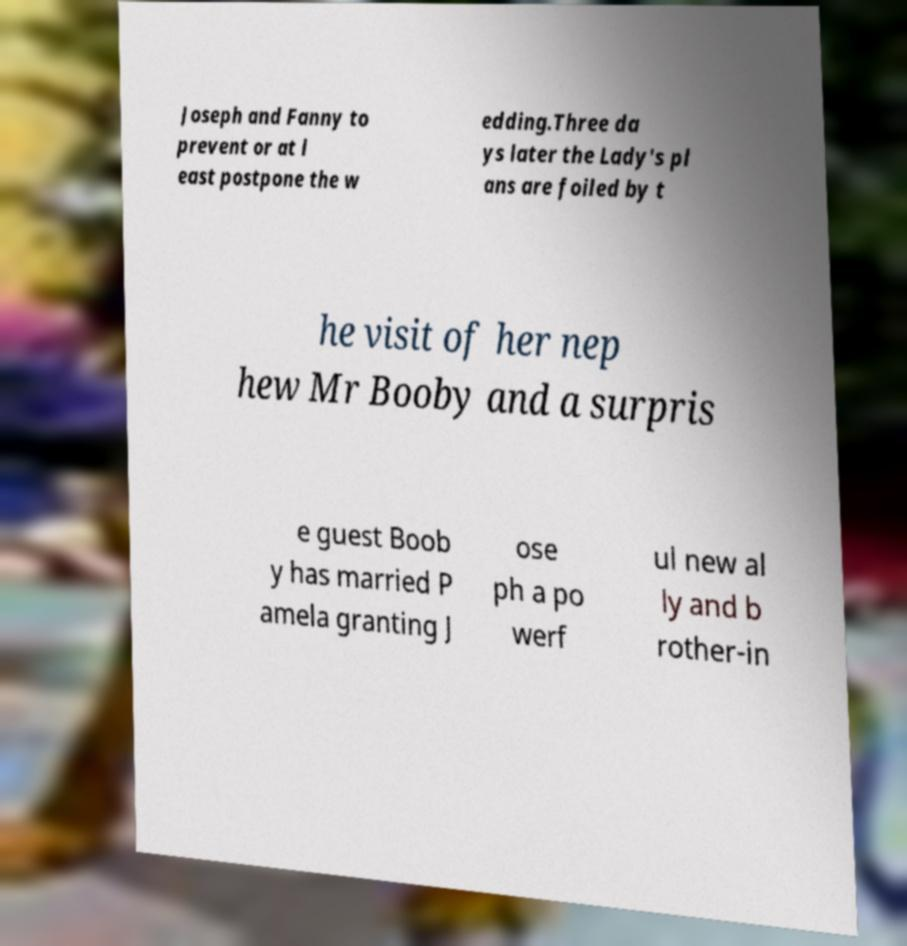There's text embedded in this image that I need extracted. Can you transcribe it verbatim? Joseph and Fanny to prevent or at l east postpone the w edding.Three da ys later the Lady's pl ans are foiled by t he visit of her nep hew Mr Booby and a surpris e guest Boob y has married P amela granting J ose ph a po werf ul new al ly and b rother-in 